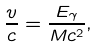<formula> <loc_0><loc_0><loc_500><loc_500>\frac { v } { c } = \frac { E _ { \gamma } } { M c ^ { 2 } } ,</formula> 